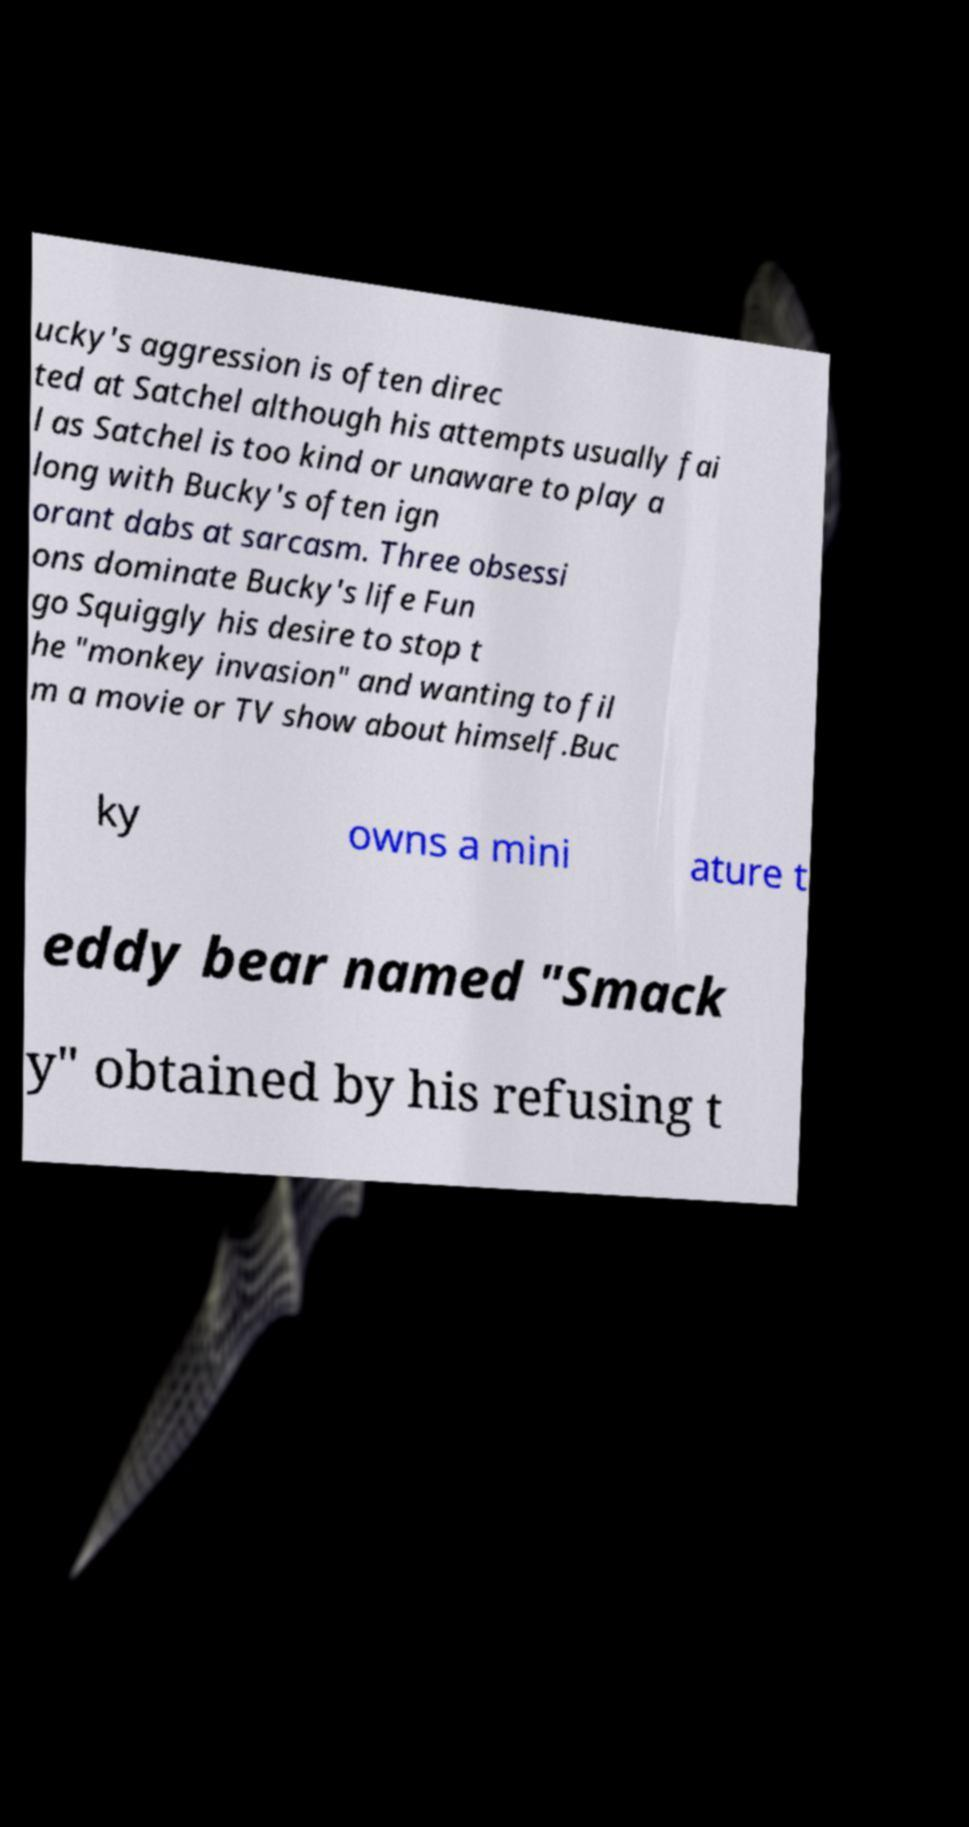Please read and relay the text visible in this image. What does it say? ucky's aggression is often direc ted at Satchel although his attempts usually fai l as Satchel is too kind or unaware to play a long with Bucky's often ign orant dabs at sarcasm. Three obsessi ons dominate Bucky's life Fun go Squiggly his desire to stop t he "monkey invasion" and wanting to fil m a movie or TV show about himself.Buc ky owns a mini ature t eddy bear named "Smack y" obtained by his refusing t 